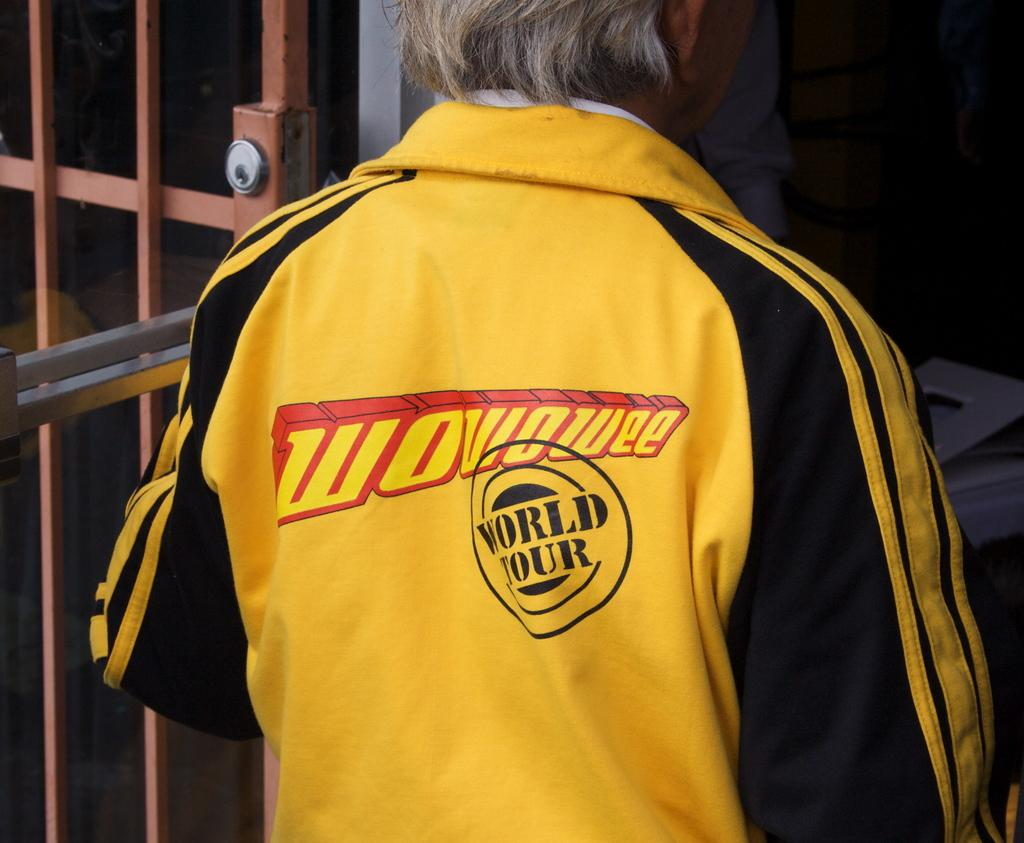<image>
Relay a brief, clear account of the picture shown. Black and yellow jacket with World Tour on it. 